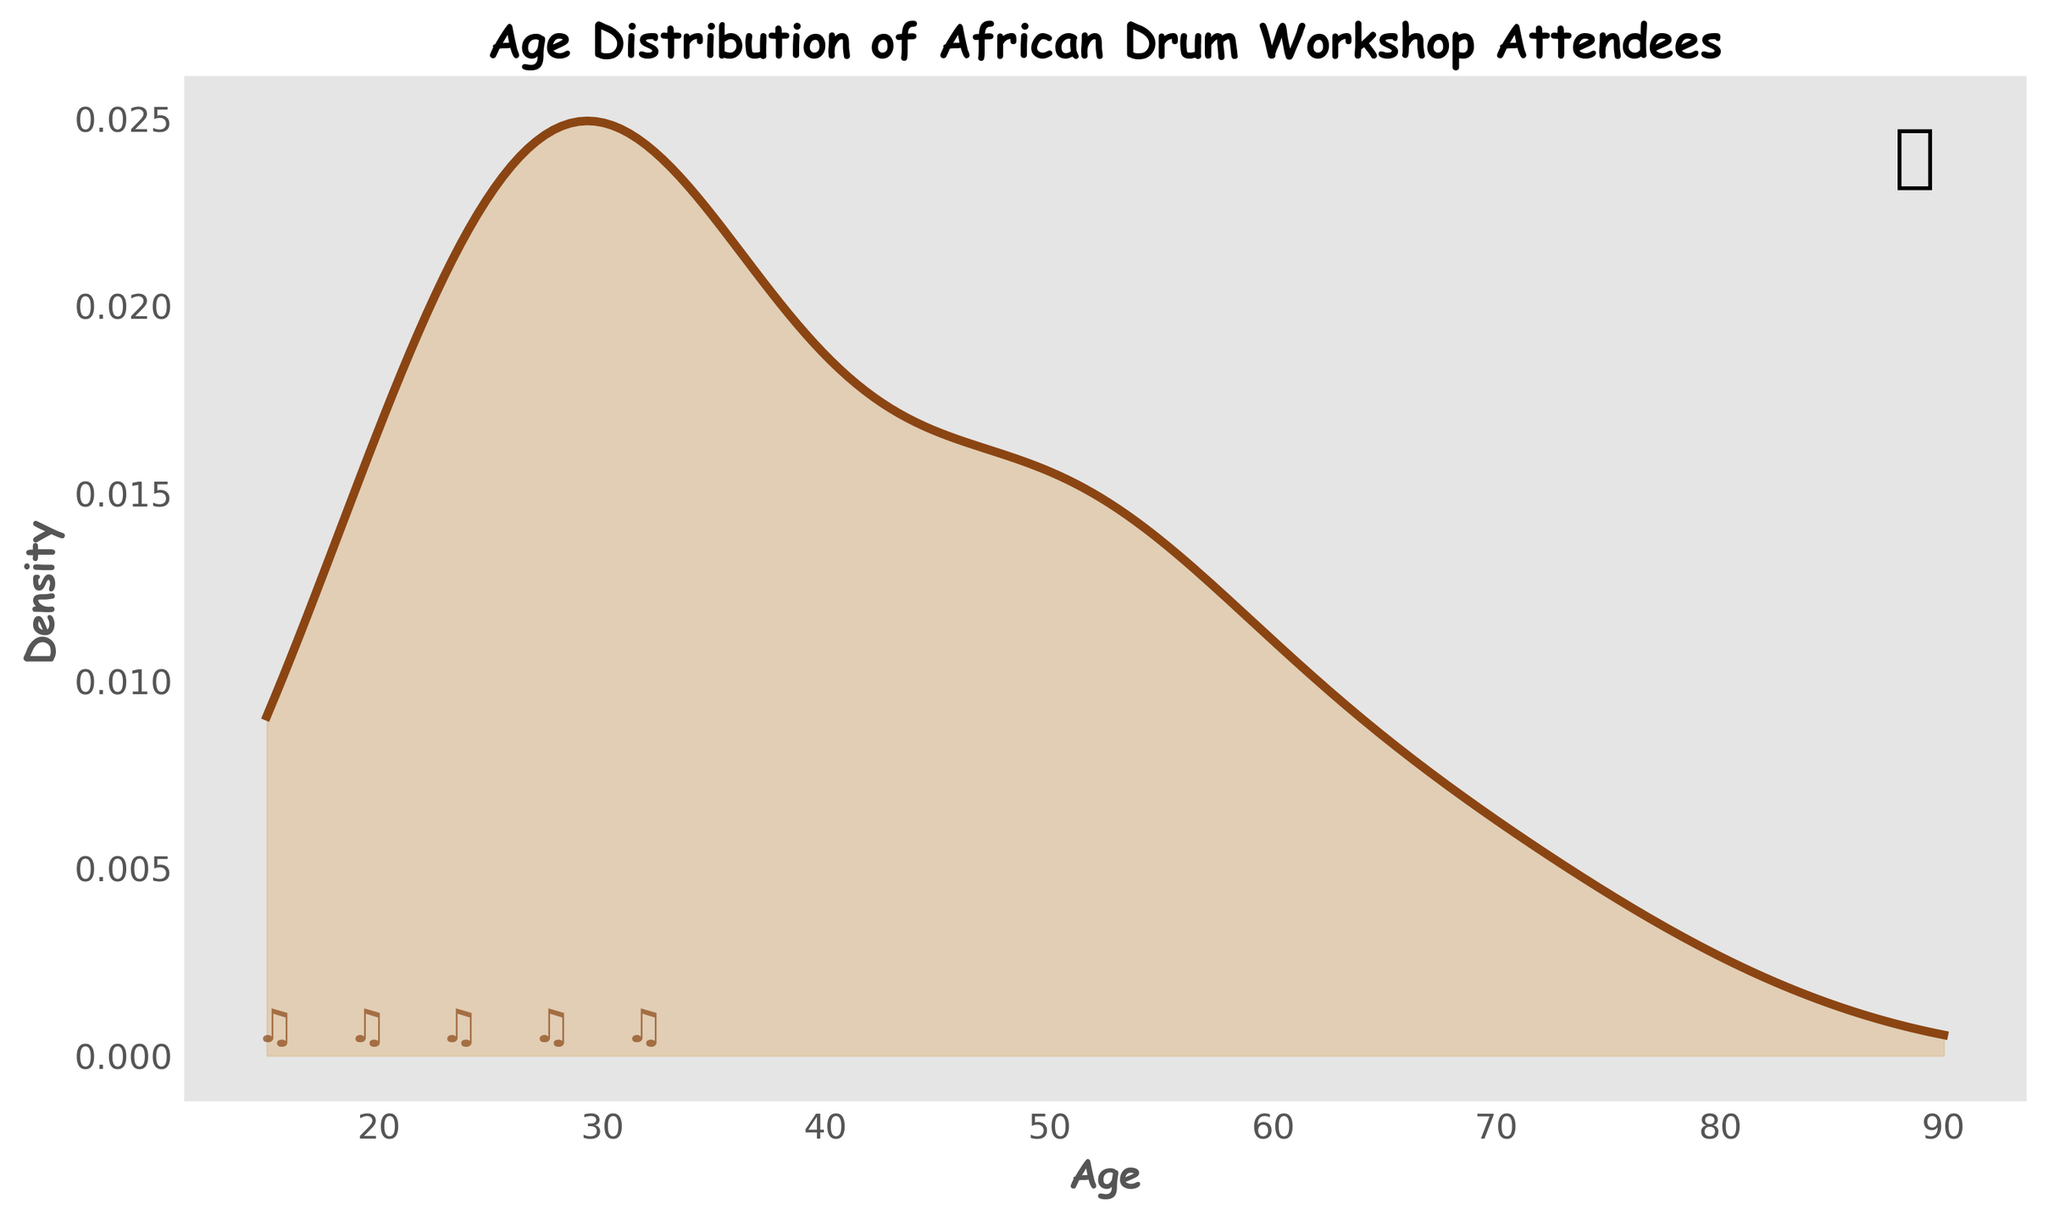what is the title of the figure? The title is located at the top of the plot and is written in bold. It describes the subject of the density plot.
Answer: Age Distribution of African Drum Workshop Attendees What are the labels on the x and y axes? The x-axis label, found at the bottom of the plot, indicates what the horizontal axis represents. The y-axis label, found on the left side of the plot, indicates what the vertical axis represents.
Answer: x-axis: Age; y-axis: Density What is the color of the line in the density plot? The line color is a distinguishing feature and can be seen tracing along the pattern of the density curve.
Answer: Brown Which age range has the highest density of attendees? Observing the peak of the density curve allows us to see which age group corresponds to the highest density value.
Answer: 26-35 Are there more attendees aged 18-25 or 56-65? To answer this, look at the relative height and span of the curve over these two age ranges. The higher the density, the more attendees there are.
Answer: 18-25 What can you tell about the shape of the distribution? By analyzing the overall shape of the density plot, we can infer if the distribution is skewed, symmetric, or has multiple peaks. This involves looking at the spread and symmetry of the curve.
Answer: The distribution is slightly skewed towards the younger age groups What is the average age of the attendees? Calculating the average age involves taking the midpoint of each age range, multiplying by the attendee count, summing up these products, and dividing by the total number of attendees. The computation would look something like: (10*21.5 + 15*30.5 + 7*40.5 + 9*50.5 + 5*60.5 + 3*70.5 + 1*80.5) / 50.
Answer: Approximately 38.6 Which age group has the least number of attendees and what is its density value? Identify the age group with the lowest count of attendees from the plot. Trace this to find the corresponding density value on the y-axis.
Answer: 76-85, density is low but specific value is not marked Between which ages do the densities start to decrease significantly? Examine the plot to determine the age range where the density begins to show a significant decline, indicated by the curve trending downwards visibly after a certain age.
Answer: Around 36-45 